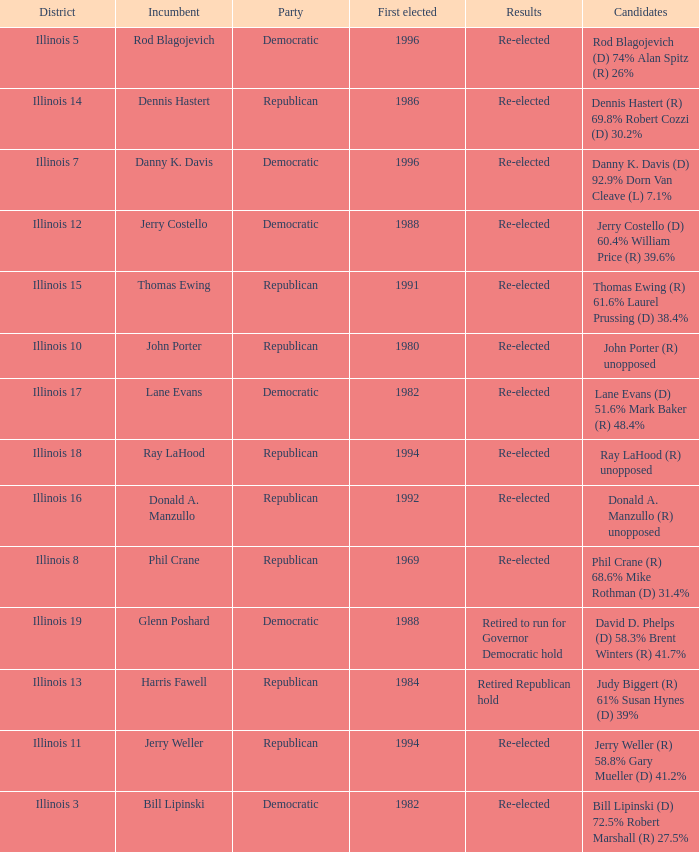What was the result in Illinois 7? Re-elected. 